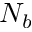<formula> <loc_0><loc_0><loc_500><loc_500>N _ { b }</formula> 